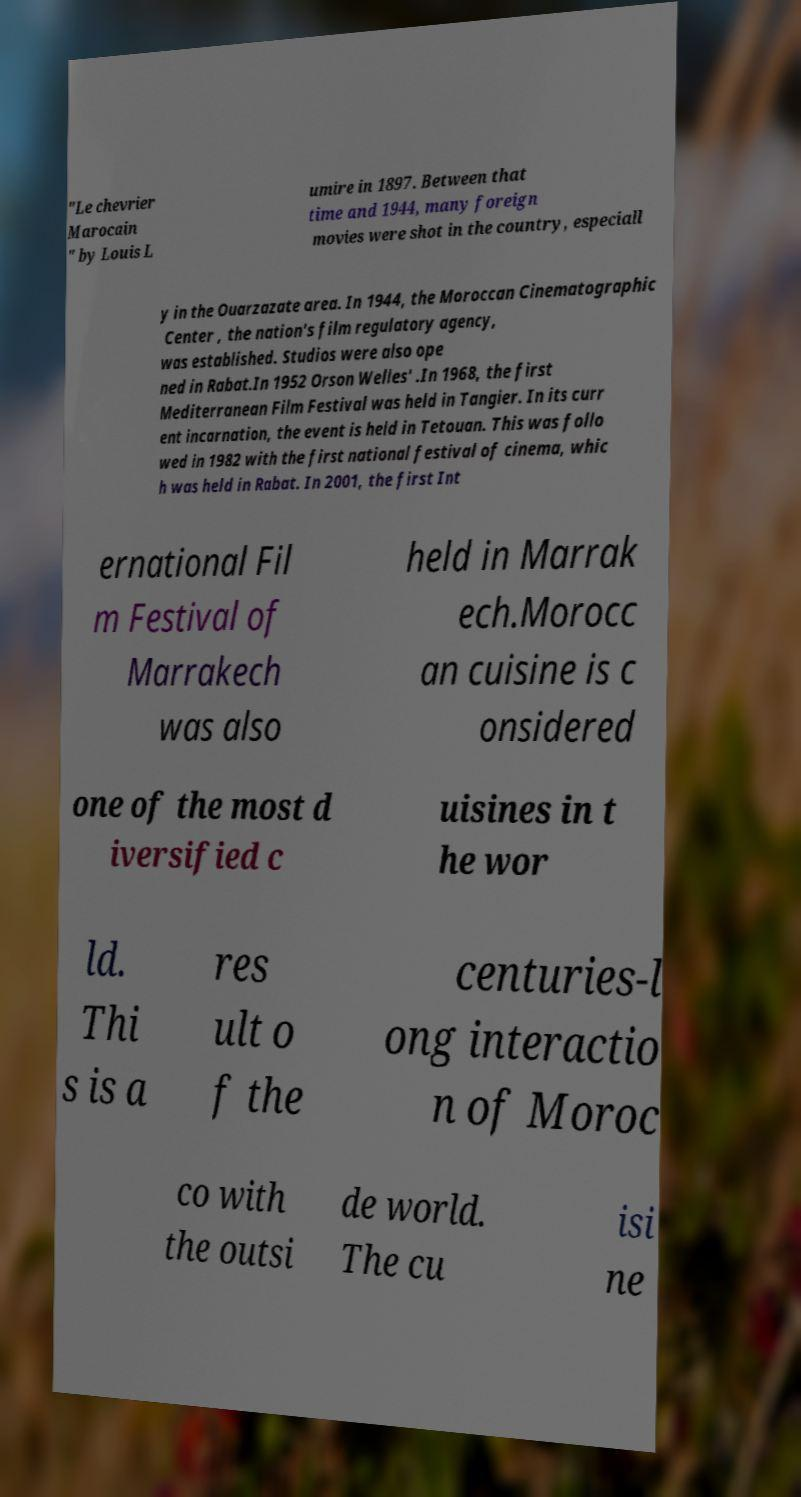There's text embedded in this image that I need extracted. Can you transcribe it verbatim? "Le chevrier Marocain " by Louis L umire in 1897. Between that time and 1944, many foreign movies were shot in the country, especiall y in the Ouarzazate area. In 1944, the Moroccan Cinematographic Center , the nation's film regulatory agency, was established. Studios were also ope ned in Rabat.In 1952 Orson Welles' .In 1968, the first Mediterranean Film Festival was held in Tangier. In its curr ent incarnation, the event is held in Tetouan. This was follo wed in 1982 with the first national festival of cinema, whic h was held in Rabat. In 2001, the first Int ernational Fil m Festival of Marrakech was also held in Marrak ech.Morocc an cuisine is c onsidered one of the most d iversified c uisines in t he wor ld. Thi s is a res ult o f the centuries-l ong interactio n of Moroc co with the outsi de world. The cu isi ne 